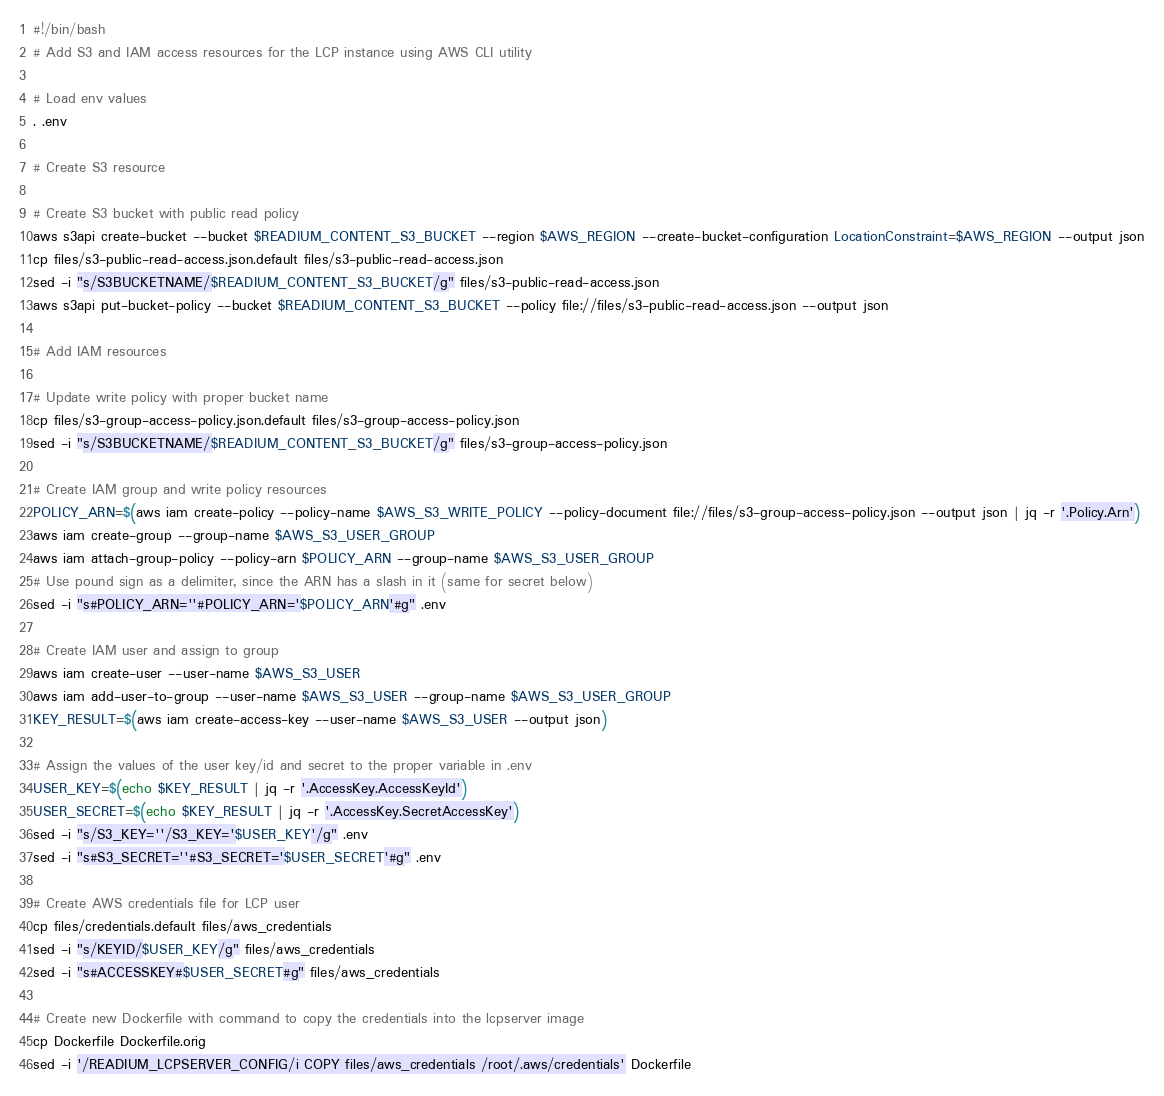<code> <loc_0><loc_0><loc_500><loc_500><_Bash_>#!/bin/bash
# Add S3 and IAM access resources for the LCP instance using AWS CLI utility

# Load env values
. .env

# Create S3 resource

# Create S3 bucket with public read policy
aws s3api create-bucket --bucket $READIUM_CONTENT_S3_BUCKET --region $AWS_REGION --create-bucket-configuration LocationConstraint=$AWS_REGION --output json
cp files/s3-public-read-access.json.default files/s3-public-read-access.json
sed -i "s/S3BUCKETNAME/$READIUM_CONTENT_S3_BUCKET/g" files/s3-public-read-access.json
aws s3api put-bucket-policy --bucket $READIUM_CONTENT_S3_BUCKET --policy file://files/s3-public-read-access.json --output json

# Add IAM resources

# Update write policy with proper bucket name
cp files/s3-group-access-policy.json.default files/s3-group-access-policy.json
sed -i "s/S3BUCKETNAME/$READIUM_CONTENT_S3_BUCKET/g" files/s3-group-access-policy.json

# Create IAM group and write policy resources
POLICY_ARN=$(aws iam create-policy --policy-name $AWS_S3_WRITE_POLICY --policy-document file://files/s3-group-access-policy.json --output json | jq -r '.Policy.Arn')
aws iam create-group --group-name $AWS_S3_USER_GROUP
aws iam attach-group-policy --policy-arn $POLICY_ARN --group-name $AWS_S3_USER_GROUP
# Use pound sign as a delimiter, since the ARN has a slash in it (same for secret below)
sed -i "s#POLICY_ARN=''#POLICY_ARN='$POLICY_ARN'#g" .env

# Create IAM user and assign to group
aws iam create-user --user-name $AWS_S3_USER
aws iam add-user-to-group --user-name $AWS_S3_USER --group-name $AWS_S3_USER_GROUP
KEY_RESULT=$(aws iam create-access-key --user-name $AWS_S3_USER --output json)

# Assign the values of the user key/id and secret to the proper variable in .env
USER_KEY=$(echo $KEY_RESULT | jq -r '.AccessKey.AccessKeyId')
USER_SECRET=$(echo $KEY_RESULT | jq -r '.AccessKey.SecretAccessKey')
sed -i "s/S3_KEY=''/S3_KEY='$USER_KEY'/g" .env
sed -i "s#S3_SECRET=''#S3_SECRET='$USER_SECRET'#g" .env

# Create AWS credentials file for LCP user
cp files/credentials.default files/aws_credentials
sed -i "s/KEYID/$USER_KEY/g" files/aws_credentials
sed -i "s#ACCESSKEY#$USER_SECRET#g" files/aws_credentials

# Create new Dockerfile with command to copy the credentials into the lcpserver image
cp Dockerfile Dockerfile.orig
sed -i '/READIUM_LCPSERVER_CONFIG/i COPY files/aws_credentials /root/.aws/credentials' Dockerfile</code> 